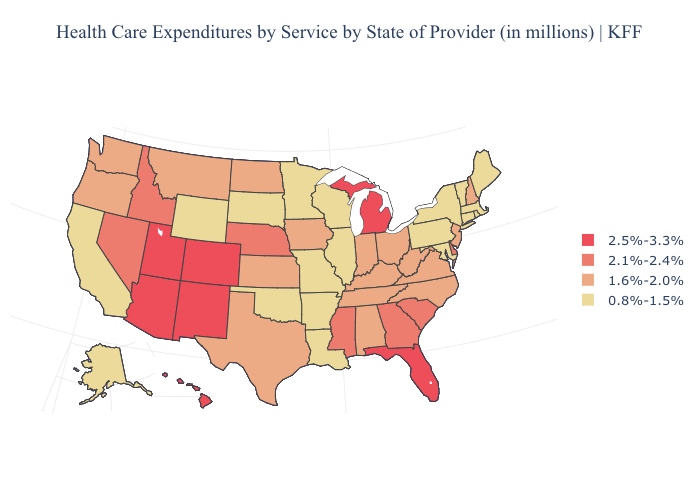What is the highest value in the West ?
Be succinct. 2.5%-3.3%. Name the states that have a value in the range 2.5%-3.3%?
Short answer required. Arizona, Colorado, Florida, Hawaii, Michigan, New Mexico, Utah. Name the states that have a value in the range 2.5%-3.3%?
Quick response, please. Arizona, Colorado, Florida, Hawaii, Michigan, New Mexico, Utah. Which states have the lowest value in the USA?
Give a very brief answer. Alaska, Arkansas, California, Connecticut, Illinois, Louisiana, Maine, Maryland, Massachusetts, Minnesota, Missouri, New York, Oklahoma, Pennsylvania, Rhode Island, South Dakota, Vermont, Wisconsin, Wyoming. Does Minnesota have the same value as Alabama?
Quick response, please. No. Does Ohio have the lowest value in the MidWest?
Keep it brief. No. Does the map have missing data?
Keep it brief. No. What is the value of Wyoming?
Short answer required. 0.8%-1.5%. Name the states that have a value in the range 2.5%-3.3%?
Be succinct. Arizona, Colorado, Florida, Hawaii, Michigan, New Mexico, Utah. Does Pennsylvania have the lowest value in the USA?
Answer briefly. Yes. Does Florida have the lowest value in the USA?
Give a very brief answer. No. What is the value of Nevada?
Quick response, please. 2.1%-2.4%. Name the states that have a value in the range 0.8%-1.5%?
Concise answer only. Alaska, Arkansas, California, Connecticut, Illinois, Louisiana, Maine, Maryland, Massachusetts, Minnesota, Missouri, New York, Oklahoma, Pennsylvania, Rhode Island, South Dakota, Vermont, Wisconsin, Wyoming. Is the legend a continuous bar?
Answer briefly. No. What is the lowest value in the West?
Concise answer only. 0.8%-1.5%. 